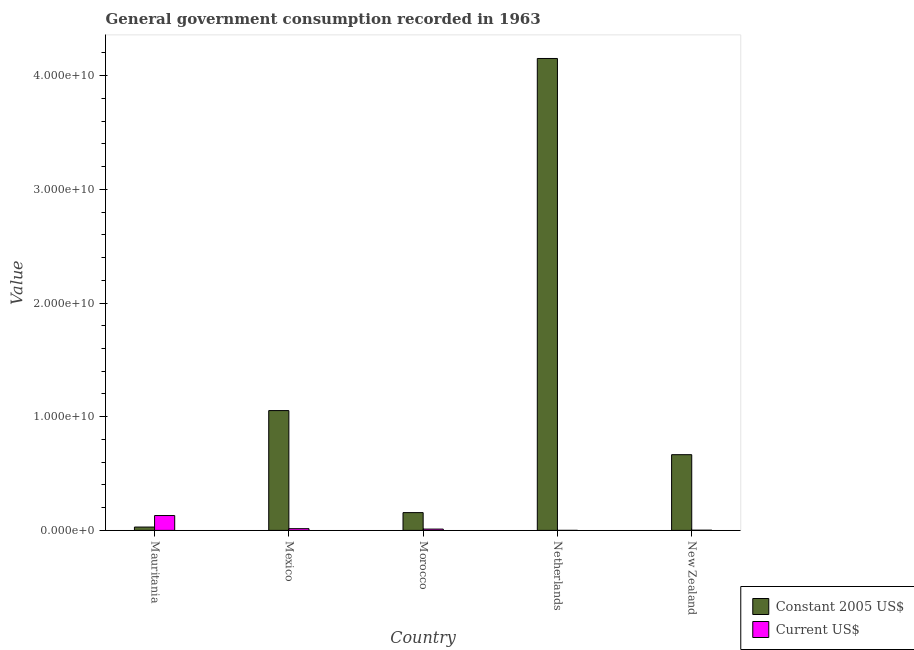Are the number of bars per tick equal to the number of legend labels?
Your answer should be very brief. Yes. How many bars are there on the 2nd tick from the left?
Offer a terse response. 2. How many bars are there on the 1st tick from the right?
Provide a short and direct response. 2. What is the label of the 3rd group of bars from the left?
Provide a short and direct response. Morocco. In how many cases, is the number of bars for a given country not equal to the number of legend labels?
Offer a terse response. 0. What is the value consumed in constant 2005 us$ in Morocco?
Offer a terse response. 1.56e+09. Across all countries, what is the maximum value consumed in constant 2005 us$?
Your answer should be compact. 4.15e+1. Across all countries, what is the minimum value consumed in constant 2005 us$?
Keep it short and to the point. 2.94e+08. In which country was the value consumed in current us$ maximum?
Your answer should be compact. Mauritania. In which country was the value consumed in current us$ minimum?
Provide a short and direct response. Netherlands. What is the total value consumed in constant 2005 us$ in the graph?
Keep it short and to the point. 6.06e+1. What is the difference between the value consumed in constant 2005 us$ in Mauritania and that in New Zealand?
Your answer should be very brief. -6.37e+09. What is the difference between the value consumed in current us$ in New Zealand and the value consumed in constant 2005 us$ in Netherlands?
Provide a short and direct response. -4.15e+1. What is the average value consumed in current us$ per country?
Provide a succinct answer. 3.18e+08. What is the difference between the value consumed in constant 2005 us$ and value consumed in current us$ in Mexico?
Provide a short and direct response. 1.04e+1. What is the ratio of the value consumed in constant 2005 us$ in Mauritania to that in New Zealand?
Ensure brevity in your answer.  0.04. Is the value consumed in constant 2005 us$ in Morocco less than that in Netherlands?
Your response must be concise. Yes. What is the difference between the highest and the second highest value consumed in current us$?
Your response must be concise. 1.15e+09. What is the difference between the highest and the lowest value consumed in constant 2005 us$?
Your answer should be very brief. 4.12e+1. What does the 2nd bar from the left in Netherlands represents?
Give a very brief answer. Current US$. What does the 2nd bar from the right in New Zealand represents?
Your answer should be very brief. Constant 2005 US$. Are all the bars in the graph horizontal?
Keep it short and to the point. No. How many countries are there in the graph?
Ensure brevity in your answer.  5. What is the difference between two consecutive major ticks on the Y-axis?
Make the answer very short. 1.00e+1. Are the values on the major ticks of Y-axis written in scientific E-notation?
Your answer should be compact. Yes. Does the graph contain any zero values?
Your answer should be very brief. No. Does the graph contain grids?
Your answer should be compact. No. What is the title of the graph?
Keep it short and to the point. General government consumption recorded in 1963. What is the label or title of the X-axis?
Your response must be concise. Country. What is the label or title of the Y-axis?
Provide a succinct answer. Value. What is the Value in Constant 2005 US$ in Mauritania?
Provide a short and direct response. 2.94e+08. What is the Value of Current US$ in Mauritania?
Your answer should be very brief. 1.31e+09. What is the Value of Constant 2005 US$ in Mexico?
Ensure brevity in your answer.  1.05e+1. What is the Value of Current US$ in Mexico?
Your answer should be very brief. 1.52e+08. What is the Value of Constant 2005 US$ in Morocco?
Give a very brief answer. 1.56e+09. What is the Value of Current US$ in Morocco?
Provide a succinct answer. 1.15e+08. What is the Value of Constant 2005 US$ in Netherlands?
Offer a very short reply. 4.15e+1. What is the Value of Current US$ in Netherlands?
Your answer should be very brief. 9.71e+05. What is the Value of Constant 2005 US$ in New Zealand?
Provide a short and direct response. 6.66e+09. What is the Value of Current US$ in New Zealand?
Offer a terse response. 1.76e+07. Across all countries, what is the maximum Value of Constant 2005 US$?
Give a very brief answer. 4.15e+1. Across all countries, what is the maximum Value of Current US$?
Ensure brevity in your answer.  1.31e+09. Across all countries, what is the minimum Value of Constant 2005 US$?
Provide a succinct answer. 2.94e+08. Across all countries, what is the minimum Value of Current US$?
Keep it short and to the point. 9.71e+05. What is the total Value of Constant 2005 US$ in the graph?
Give a very brief answer. 6.06e+1. What is the total Value in Current US$ in the graph?
Provide a succinct answer. 1.59e+09. What is the difference between the Value in Constant 2005 US$ in Mauritania and that in Mexico?
Make the answer very short. -1.02e+1. What is the difference between the Value in Current US$ in Mauritania and that in Mexico?
Ensure brevity in your answer.  1.15e+09. What is the difference between the Value of Constant 2005 US$ in Mauritania and that in Morocco?
Your answer should be compact. -1.27e+09. What is the difference between the Value of Current US$ in Mauritania and that in Morocco?
Your answer should be very brief. 1.19e+09. What is the difference between the Value of Constant 2005 US$ in Mauritania and that in Netherlands?
Your answer should be compact. -4.12e+1. What is the difference between the Value of Current US$ in Mauritania and that in Netherlands?
Your answer should be compact. 1.31e+09. What is the difference between the Value of Constant 2005 US$ in Mauritania and that in New Zealand?
Ensure brevity in your answer.  -6.37e+09. What is the difference between the Value of Current US$ in Mauritania and that in New Zealand?
Provide a short and direct response. 1.29e+09. What is the difference between the Value in Constant 2005 US$ in Mexico and that in Morocco?
Your answer should be very brief. 8.98e+09. What is the difference between the Value of Current US$ in Mexico and that in Morocco?
Make the answer very short. 3.66e+07. What is the difference between the Value in Constant 2005 US$ in Mexico and that in Netherlands?
Make the answer very short. -3.10e+1. What is the difference between the Value in Current US$ in Mexico and that in Netherlands?
Ensure brevity in your answer.  1.51e+08. What is the difference between the Value of Constant 2005 US$ in Mexico and that in New Zealand?
Your answer should be compact. 3.88e+09. What is the difference between the Value in Current US$ in Mexico and that in New Zealand?
Keep it short and to the point. 1.34e+08. What is the difference between the Value in Constant 2005 US$ in Morocco and that in Netherlands?
Ensure brevity in your answer.  -4.00e+1. What is the difference between the Value in Current US$ in Morocco and that in Netherlands?
Offer a terse response. 1.14e+08. What is the difference between the Value in Constant 2005 US$ in Morocco and that in New Zealand?
Ensure brevity in your answer.  -5.10e+09. What is the difference between the Value of Current US$ in Morocco and that in New Zealand?
Your answer should be very brief. 9.76e+07. What is the difference between the Value in Constant 2005 US$ in Netherlands and that in New Zealand?
Keep it short and to the point. 3.49e+1. What is the difference between the Value in Current US$ in Netherlands and that in New Zealand?
Make the answer very short. -1.67e+07. What is the difference between the Value in Constant 2005 US$ in Mauritania and the Value in Current US$ in Mexico?
Provide a succinct answer. 1.42e+08. What is the difference between the Value of Constant 2005 US$ in Mauritania and the Value of Current US$ in Morocco?
Ensure brevity in your answer.  1.79e+08. What is the difference between the Value of Constant 2005 US$ in Mauritania and the Value of Current US$ in Netherlands?
Ensure brevity in your answer.  2.93e+08. What is the difference between the Value in Constant 2005 US$ in Mauritania and the Value in Current US$ in New Zealand?
Offer a terse response. 2.76e+08. What is the difference between the Value of Constant 2005 US$ in Mexico and the Value of Current US$ in Morocco?
Offer a terse response. 1.04e+1. What is the difference between the Value in Constant 2005 US$ in Mexico and the Value in Current US$ in Netherlands?
Offer a very short reply. 1.05e+1. What is the difference between the Value of Constant 2005 US$ in Mexico and the Value of Current US$ in New Zealand?
Keep it short and to the point. 1.05e+1. What is the difference between the Value in Constant 2005 US$ in Morocco and the Value in Current US$ in Netherlands?
Give a very brief answer. 1.56e+09. What is the difference between the Value of Constant 2005 US$ in Morocco and the Value of Current US$ in New Zealand?
Provide a short and direct response. 1.55e+09. What is the difference between the Value in Constant 2005 US$ in Netherlands and the Value in Current US$ in New Zealand?
Keep it short and to the point. 4.15e+1. What is the average Value of Constant 2005 US$ per country?
Give a very brief answer. 1.21e+1. What is the average Value of Current US$ per country?
Provide a succinct answer. 3.18e+08. What is the difference between the Value of Constant 2005 US$ and Value of Current US$ in Mauritania?
Provide a short and direct response. -1.01e+09. What is the difference between the Value in Constant 2005 US$ and Value in Current US$ in Mexico?
Your answer should be very brief. 1.04e+1. What is the difference between the Value in Constant 2005 US$ and Value in Current US$ in Morocco?
Your response must be concise. 1.45e+09. What is the difference between the Value in Constant 2005 US$ and Value in Current US$ in Netherlands?
Offer a terse response. 4.15e+1. What is the difference between the Value in Constant 2005 US$ and Value in Current US$ in New Zealand?
Provide a short and direct response. 6.64e+09. What is the ratio of the Value in Constant 2005 US$ in Mauritania to that in Mexico?
Provide a succinct answer. 0.03. What is the ratio of the Value in Current US$ in Mauritania to that in Mexico?
Your answer should be compact. 8.61. What is the ratio of the Value in Constant 2005 US$ in Mauritania to that in Morocco?
Your answer should be very brief. 0.19. What is the ratio of the Value of Current US$ in Mauritania to that in Morocco?
Ensure brevity in your answer.  11.34. What is the ratio of the Value of Constant 2005 US$ in Mauritania to that in Netherlands?
Keep it short and to the point. 0.01. What is the ratio of the Value in Current US$ in Mauritania to that in Netherlands?
Ensure brevity in your answer.  1345.27. What is the ratio of the Value in Constant 2005 US$ in Mauritania to that in New Zealand?
Your response must be concise. 0.04. What is the ratio of the Value in Current US$ in Mauritania to that in New Zealand?
Provide a succinct answer. 74.12. What is the ratio of the Value of Constant 2005 US$ in Mexico to that in Morocco?
Your response must be concise. 6.74. What is the ratio of the Value of Current US$ in Mexico to that in Morocco?
Offer a very short reply. 1.32. What is the ratio of the Value of Constant 2005 US$ in Mexico to that in Netherlands?
Provide a succinct answer. 0.25. What is the ratio of the Value of Current US$ in Mexico to that in Netherlands?
Your response must be concise. 156.28. What is the ratio of the Value in Constant 2005 US$ in Mexico to that in New Zealand?
Your response must be concise. 1.58. What is the ratio of the Value of Current US$ in Mexico to that in New Zealand?
Provide a short and direct response. 8.61. What is the ratio of the Value of Constant 2005 US$ in Morocco to that in Netherlands?
Your answer should be very brief. 0.04. What is the ratio of the Value of Current US$ in Morocco to that in Netherlands?
Offer a terse response. 118.61. What is the ratio of the Value of Constant 2005 US$ in Morocco to that in New Zealand?
Make the answer very short. 0.23. What is the ratio of the Value of Current US$ in Morocco to that in New Zealand?
Ensure brevity in your answer.  6.53. What is the ratio of the Value in Constant 2005 US$ in Netherlands to that in New Zealand?
Provide a succinct answer. 6.23. What is the ratio of the Value in Current US$ in Netherlands to that in New Zealand?
Provide a succinct answer. 0.06. What is the difference between the highest and the second highest Value in Constant 2005 US$?
Provide a short and direct response. 3.10e+1. What is the difference between the highest and the second highest Value of Current US$?
Ensure brevity in your answer.  1.15e+09. What is the difference between the highest and the lowest Value in Constant 2005 US$?
Your answer should be very brief. 4.12e+1. What is the difference between the highest and the lowest Value of Current US$?
Ensure brevity in your answer.  1.31e+09. 